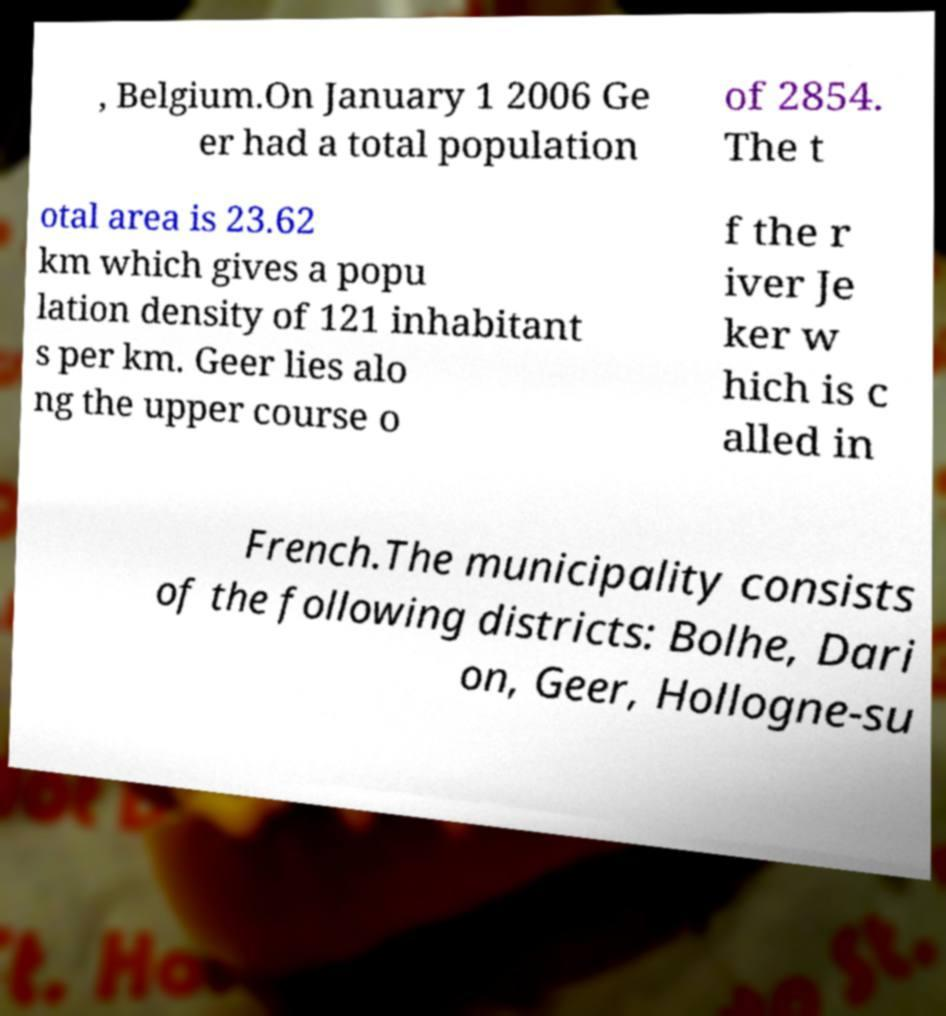Can you read and provide the text displayed in the image?This photo seems to have some interesting text. Can you extract and type it out for me? , Belgium.On January 1 2006 Ge er had a total population of 2854. The t otal area is 23.62 km which gives a popu lation density of 121 inhabitant s per km. Geer lies alo ng the upper course o f the r iver Je ker w hich is c alled in French.The municipality consists of the following districts: Bolhe, Dari on, Geer, Hollogne-su 